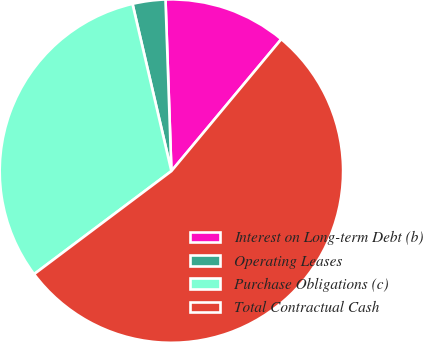Convert chart to OTSL. <chart><loc_0><loc_0><loc_500><loc_500><pie_chart><fcel>Interest on Long-term Debt (b)<fcel>Operating Leases<fcel>Purchase Obligations (c)<fcel>Total Contractual Cash<nl><fcel>11.6%<fcel>3.09%<fcel>31.61%<fcel>53.7%<nl></chart> 